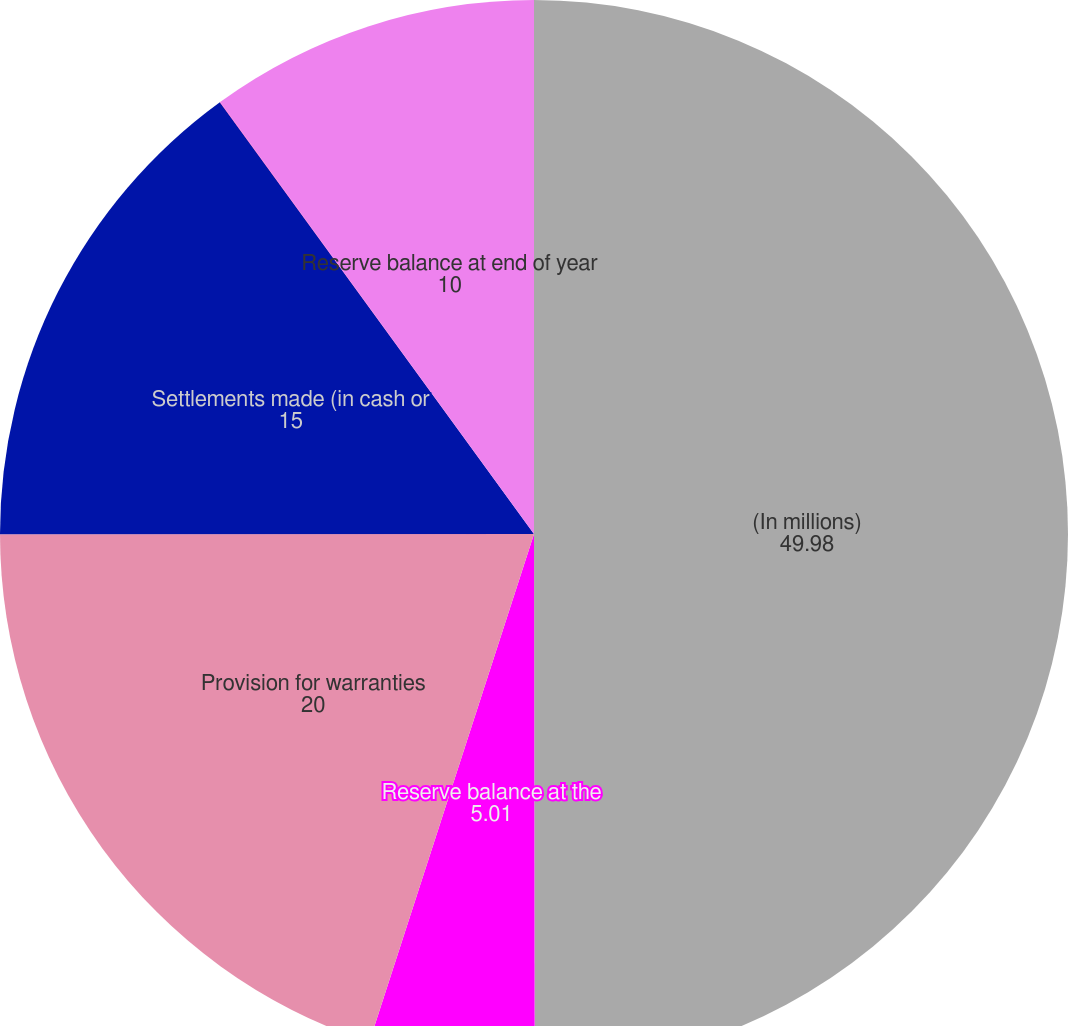Convert chart to OTSL. <chart><loc_0><loc_0><loc_500><loc_500><pie_chart><fcel>(In millions)<fcel>Reserve balance at the<fcel>Provision for warranties<fcel>Settlements made (in cash or<fcel>Foreign currency<fcel>Reserve balance at end of year<nl><fcel>49.98%<fcel>5.01%<fcel>20.0%<fcel>15.0%<fcel>0.01%<fcel>10.0%<nl></chart> 